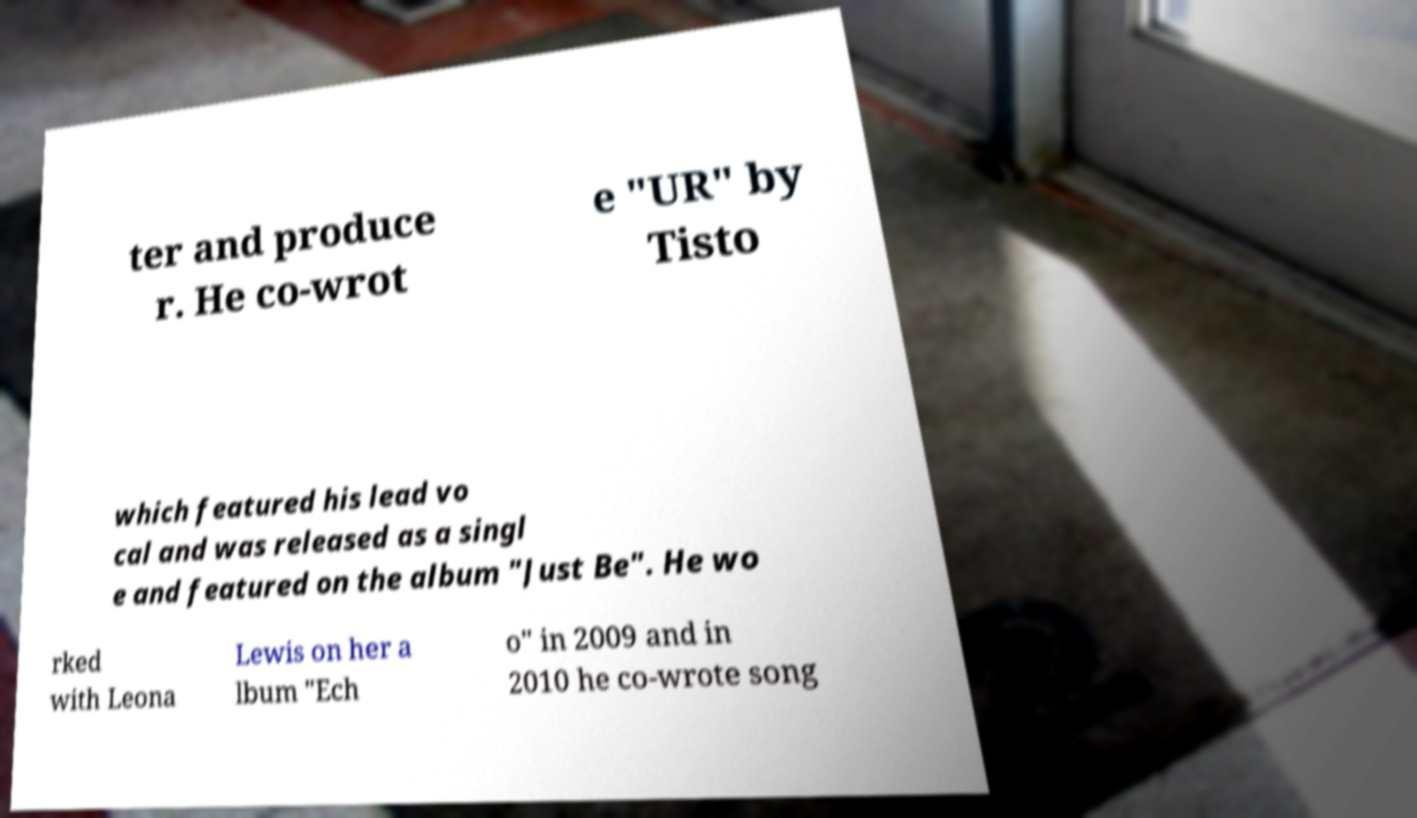I need the written content from this picture converted into text. Can you do that? ter and produce r. He co-wrot e "UR" by Tisto which featured his lead vo cal and was released as a singl e and featured on the album "Just Be". He wo rked with Leona Lewis on her a lbum "Ech o" in 2009 and in 2010 he co-wrote song 